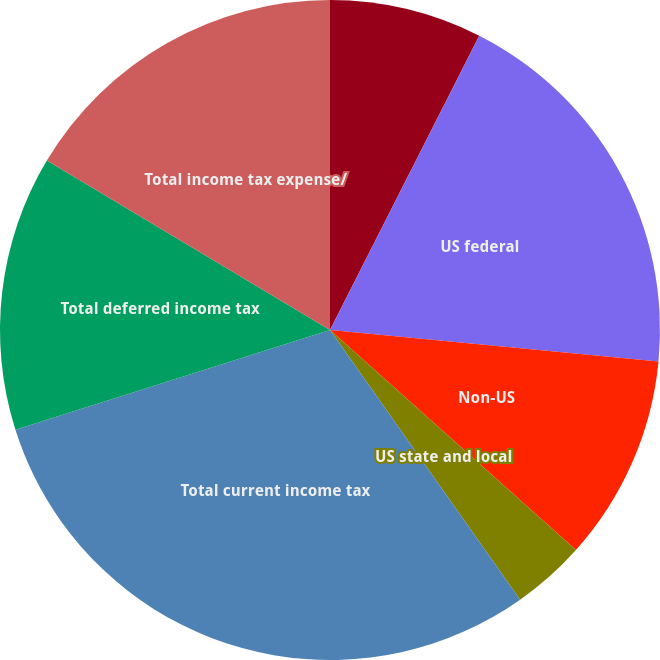Convert chart. <chart><loc_0><loc_0><loc_500><loc_500><pie_chart><fcel>Year ended December 31 (in<fcel>US federal<fcel>Non-US<fcel>US state and local<fcel>Total current income tax<fcel>Total deferred income tax<fcel>Total income tax expense/<nl><fcel>7.47%<fcel>19.05%<fcel>10.1%<fcel>3.61%<fcel>29.89%<fcel>13.47%<fcel>16.42%<nl></chart> 